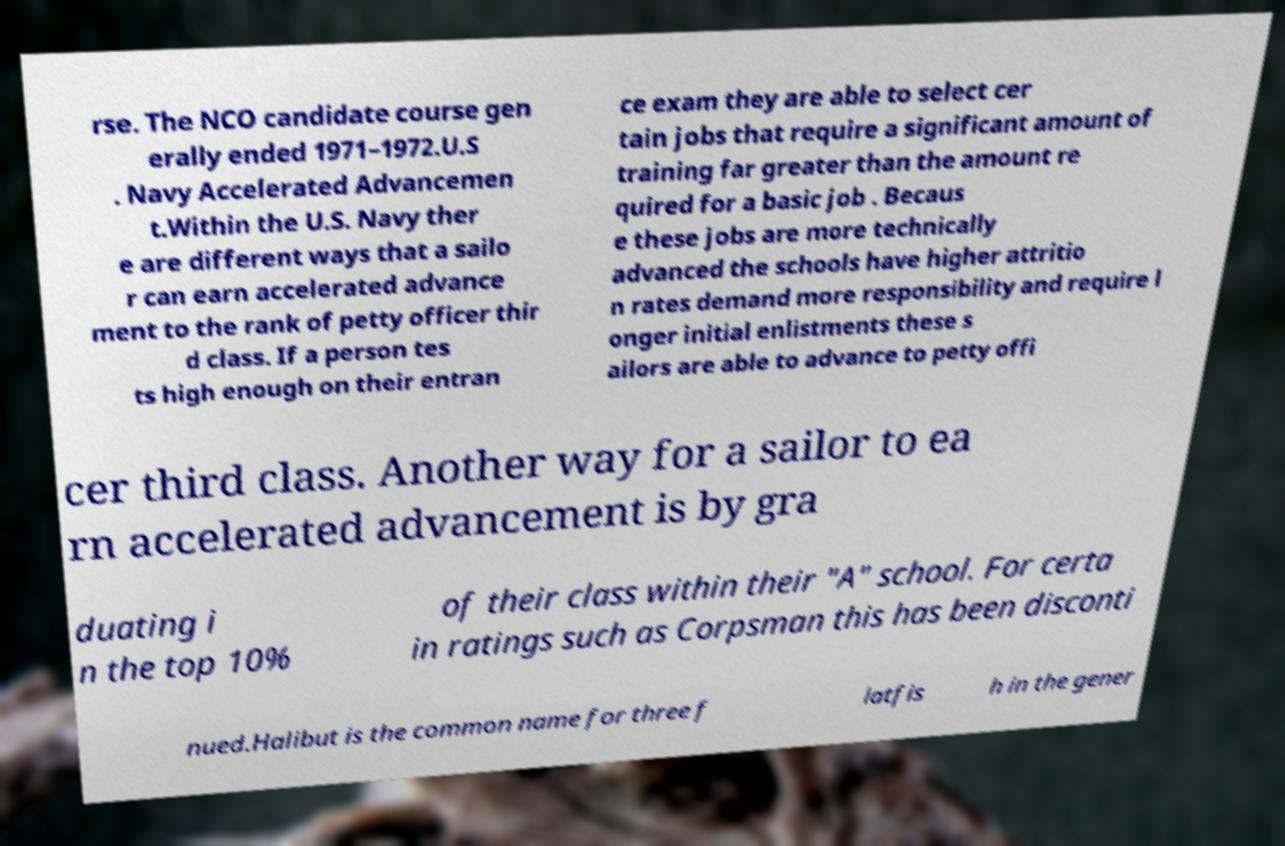Please identify and transcribe the text found in this image. rse. The NCO candidate course gen erally ended 1971–1972.U.S . Navy Accelerated Advancemen t.Within the U.S. Navy ther e are different ways that a sailo r can earn accelerated advance ment to the rank of petty officer thir d class. If a person tes ts high enough on their entran ce exam they are able to select cer tain jobs that require a significant amount of training far greater than the amount re quired for a basic job . Becaus e these jobs are more technically advanced the schools have higher attritio n rates demand more responsibility and require l onger initial enlistments these s ailors are able to advance to petty offi cer third class. Another way for a sailor to ea rn accelerated advancement is by gra duating i n the top 10% of their class within their "A" school. For certa in ratings such as Corpsman this has been disconti nued.Halibut is the common name for three f latfis h in the gener 